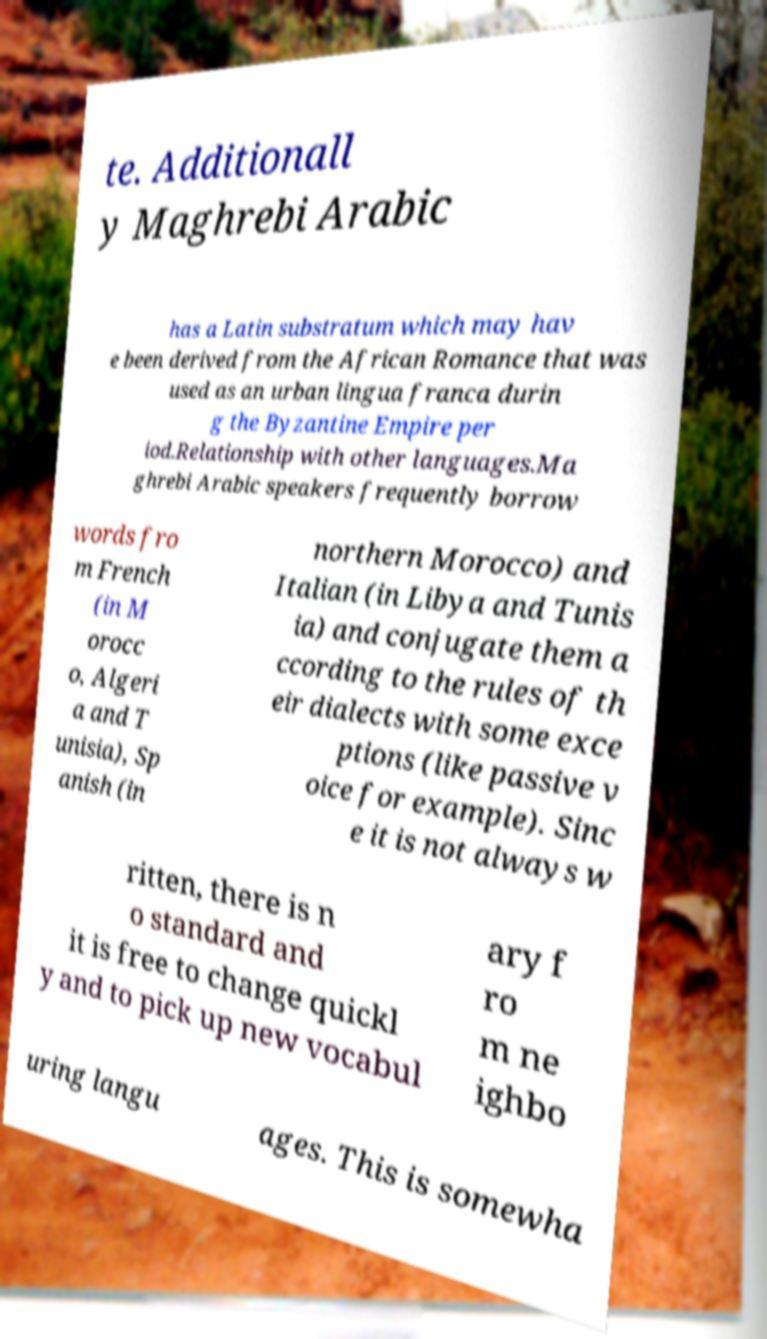I need the written content from this picture converted into text. Can you do that? te. Additionall y Maghrebi Arabic has a Latin substratum which may hav e been derived from the African Romance that was used as an urban lingua franca durin g the Byzantine Empire per iod.Relationship with other languages.Ma ghrebi Arabic speakers frequently borrow words fro m French (in M orocc o, Algeri a and T unisia), Sp anish (in northern Morocco) and Italian (in Libya and Tunis ia) and conjugate them a ccording to the rules of th eir dialects with some exce ptions (like passive v oice for example). Sinc e it is not always w ritten, there is n o standard and it is free to change quickl y and to pick up new vocabul ary f ro m ne ighbo uring langu ages. This is somewha 